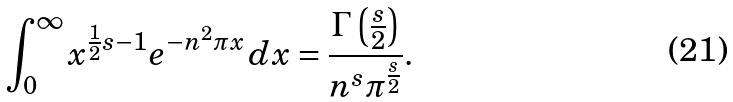<formula> <loc_0><loc_0><loc_500><loc_500>\int _ { 0 } ^ { \infty } x ^ { { \frac { 1 } { 2 } } { s } - 1 } e ^ { - n ^ { 2 } \pi x } \, d x = { \frac { \Gamma \left ( { \frac { s } { 2 } } \right ) } { n ^ { s } \pi ^ { \frac { s } { 2 } } } } .</formula> 